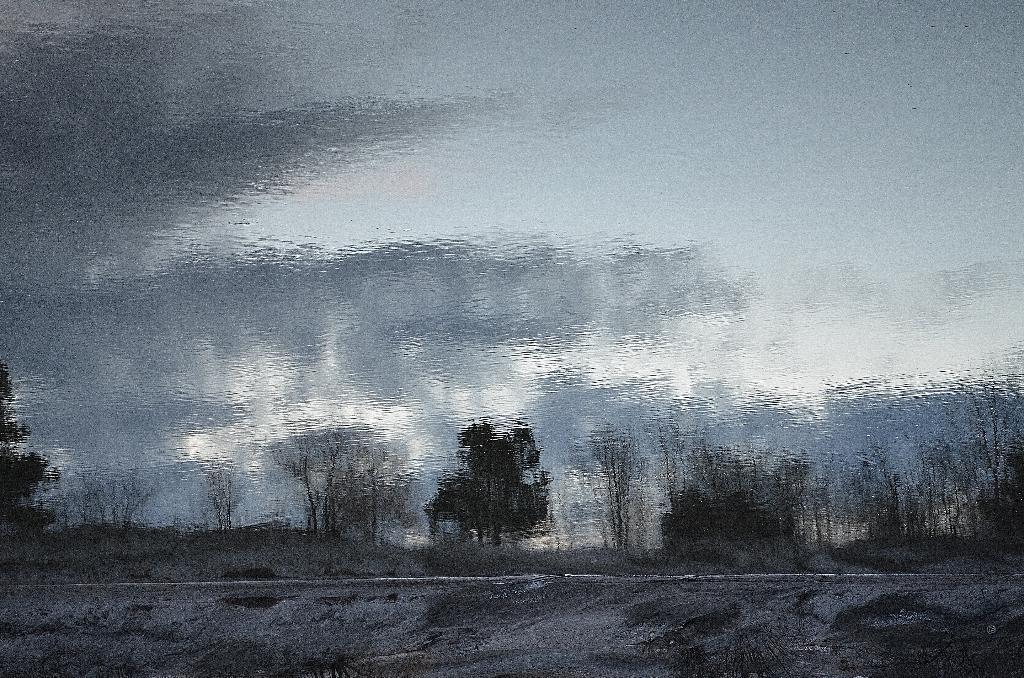Describe this image in one or two sentences. In this image we can see a painting. In painting we can see the cloudy sky. There is a road in the image. There are many trees in the image. 